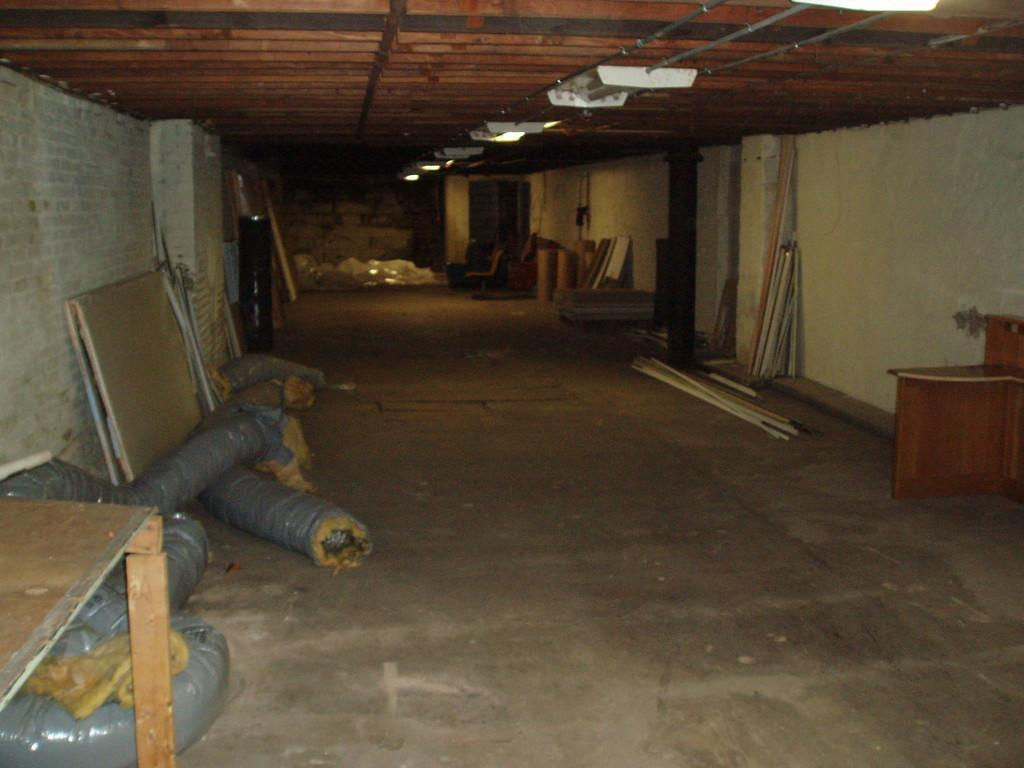What type of furniture is visible in the image? There are tables in the image. What type of material is used for the wood pieces in the image? The wood pieces in the image are made of wood. What type of plumbing equipment is visible in the image? There are pipes in the image. What type of vertical structure is present in the image? There is a pole in the image. What type of objects are placed on the floor in the image? There are objects placed on the floor in the image, but the specific objects are not mentioned in the facts. What type of barrier is present in the image? There is a wall in the image. What type of lighting is visible in the image? There are ceiling lights in the image. What type of structure is visible at the top of the image? The image shows a roof. How many stockings are hanging from the pole in the image? There are no stockings present in the image. What type of dust is visible on the wood pieces in the image? There is no dust visible on the wood pieces in the image. 